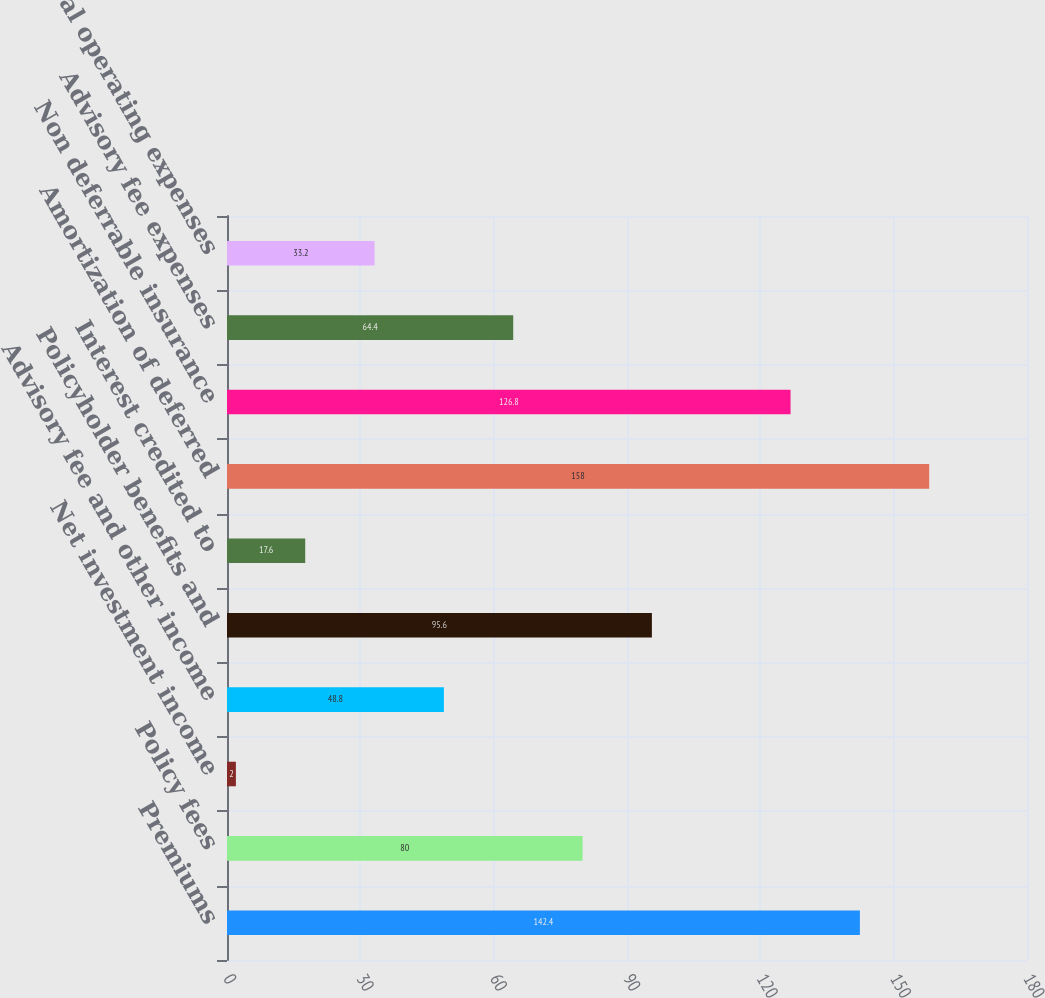Convert chart. <chart><loc_0><loc_0><loc_500><loc_500><bar_chart><fcel>Premiums<fcel>Policy fees<fcel>Net investment income<fcel>Advisory fee and other income<fcel>Policyholder benefits and<fcel>Interest credited to<fcel>Amortization of deferred<fcel>Non deferrable insurance<fcel>Advisory fee expenses<fcel>General operating expenses<nl><fcel>142.4<fcel>80<fcel>2<fcel>48.8<fcel>95.6<fcel>17.6<fcel>158<fcel>126.8<fcel>64.4<fcel>33.2<nl></chart> 